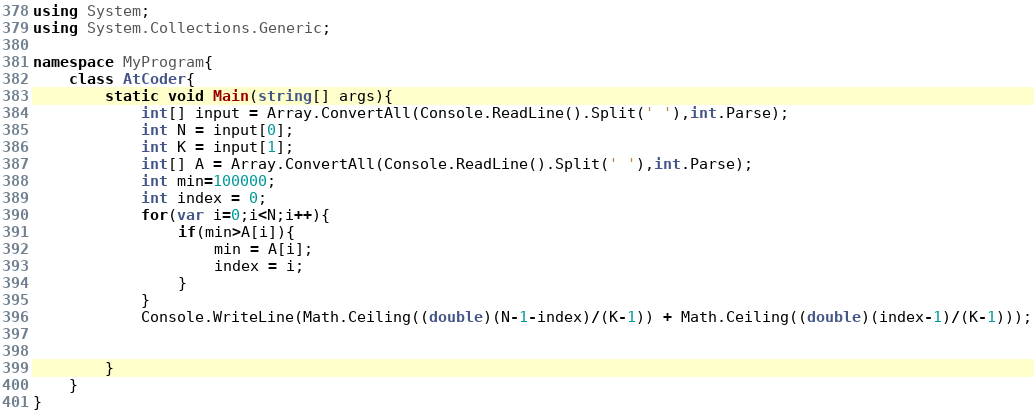<code> <loc_0><loc_0><loc_500><loc_500><_C#_>using System;
using System.Collections.Generic;

namespace MyProgram{
    class AtCoder{
        static void Main(string[] args){
            int[] input = Array.ConvertAll(Console.ReadLine().Split(' '),int.Parse);
            int N = input[0];
            int K = input[1];
            int[] A = Array.ConvertAll(Console.ReadLine().Split(' '),int.Parse);
            int min=100000;
            int index = 0;
            for(var i=0;i<N;i++){
                if(min>A[i]){
                    min = A[i];
                    index = i;
                }
            }
            Console.WriteLine(Math.Ceiling((double)(N-1-index)/(K-1)) + Math.Ceiling((double)(index-1)/(K-1)));

            
        }
    } 
}</code> 